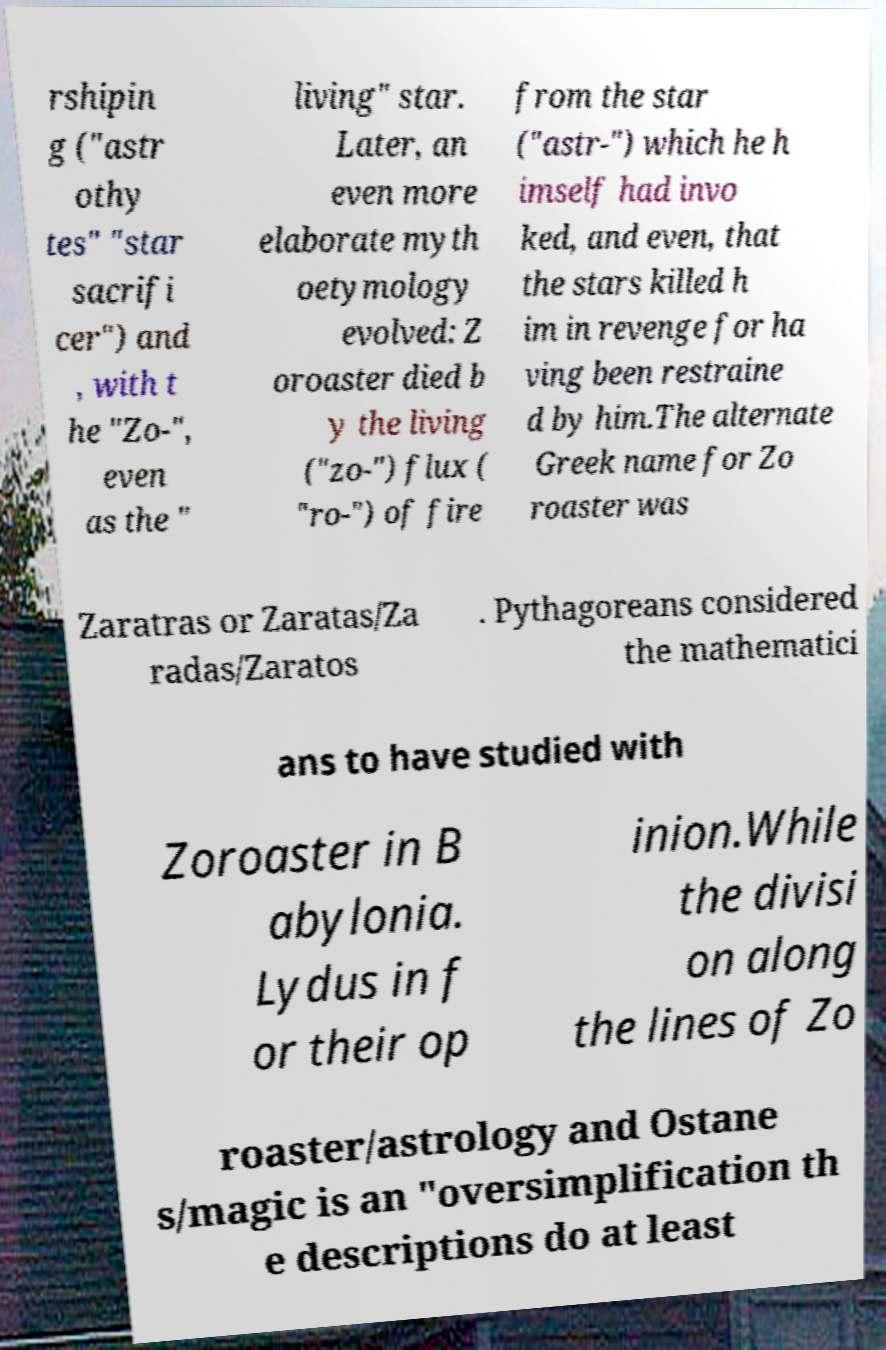Could you assist in decoding the text presented in this image and type it out clearly? rshipin g ("astr othy tes" "star sacrifi cer") and , with t he "Zo-", even as the " living" star. Later, an even more elaborate myth oetymology evolved: Z oroaster died b y the living ("zo-") flux ( "ro-") of fire from the star ("astr-") which he h imself had invo ked, and even, that the stars killed h im in revenge for ha ving been restraine d by him.The alternate Greek name for Zo roaster was Zaratras or Zaratas/Za radas/Zaratos . Pythagoreans considered the mathematici ans to have studied with Zoroaster in B abylonia. Lydus in f or their op inion.While the divisi on along the lines of Zo roaster/astrology and Ostane s/magic is an "oversimplification th e descriptions do at least 